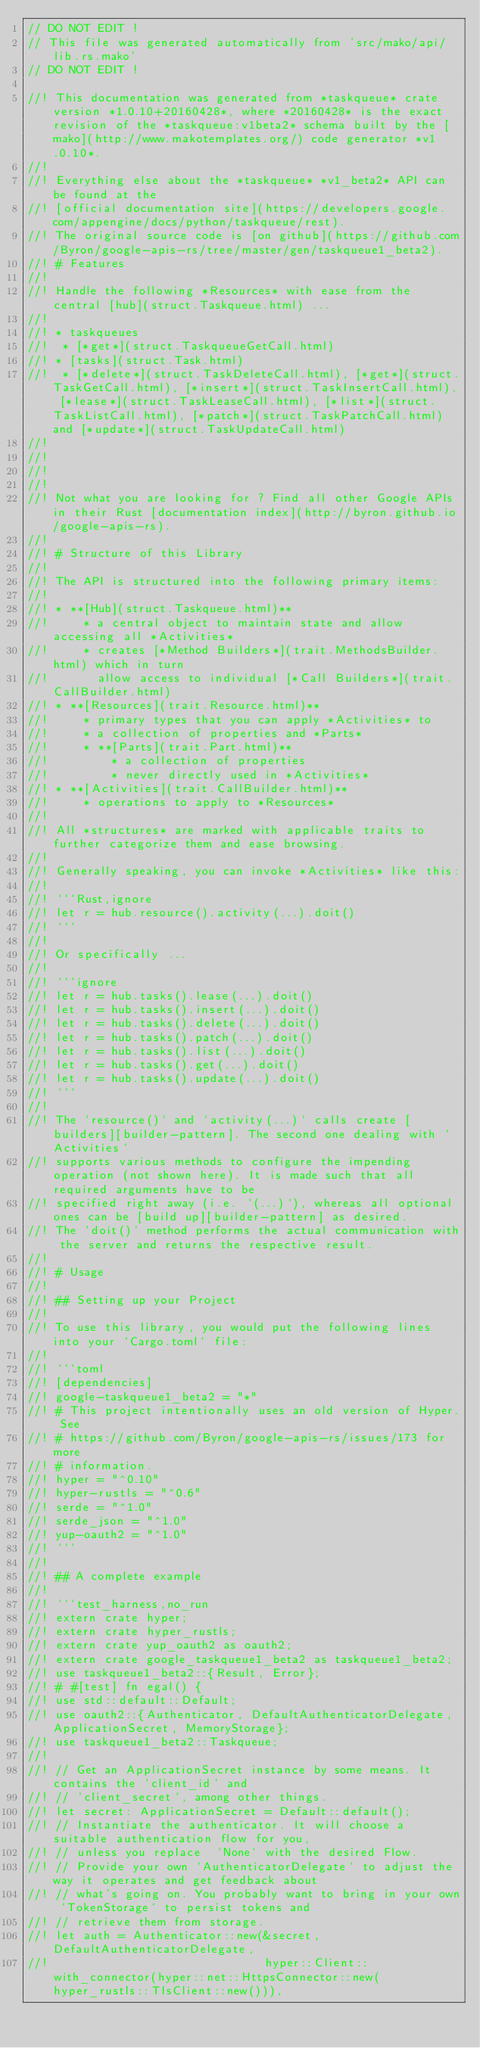<code> <loc_0><loc_0><loc_500><loc_500><_Rust_>// DO NOT EDIT !
// This file was generated automatically from 'src/mako/api/lib.rs.mako'
// DO NOT EDIT !

//! This documentation was generated from *taskqueue* crate version *1.0.10+20160428*, where *20160428* is the exact revision of the *taskqueue:v1beta2* schema built by the [mako](http://www.makotemplates.org/) code generator *v1.0.10*.
//! 
//! Everything else about the *taskqueue* *v1_beta2* API can be found at the
//! [official documentation site](https://developers.google.com/appengine/docs/python/taskqueue/rest).
//! The original source code is [on github](https://github.com/Byron/google-apis-rs/tree/master/gen/taskqueue1_beta2).
//! # Features
//! 
//! Handle the following *Resources* with ease from the central [hub](struct.Taskqueue.html) ... 
//! 
//! * taskqueues
//!  * [*get*](struct.TaskqueueGetCall.html)
//! * [tasks](struct.Task.html)
//!  * [*delete*](struct.TaskDeleteCall.html), [*get*](struct.TaskGetCall.html), [*insert*](struct.TaskInsertCall.html), [*lease*](struct.TaskLeaseCall.html), [*list*](struct.TaskListCall.html), [*patch*](struct.TaskPatchCall.html) and [*update*](struct.TaskUpdateCall.html)
//! 
//! 
//! 
//! 
//! Not what you are looking for ? Find all other Google APIs in their Rust [documentation index](http://byron.github.io/google-apis-rs).
//! 
//! # Structure of this Library
//! 
//! The API is structured into the following primary items:
//! 
//! * **[Hub](struct.Taskqueue.html)**
//!     * a central object to maintain state and allow accessing all *Activities*
//!     * creates [*Method Builders*](trait.MethodsBuilder.html) which in turn
//!       allow access to individual [*Call Builders*](trait.CallBuilder.html)
//! * **[Resources](trait.Resource.html)**
//!     * primary types that you can apply *Activities* to
//!     * a collection of properties and *Parts*
//!     * **[Parts](trait.Part.html)**
//!         * a collection of properties
//!         * never directly used in *Activities*
//! * **[Activities](trait.CallBuilder.html)**
//!     * operations to apply to *Resources*
//! 
//! All *structures* are marked with applicable traits to further categorize them and ease browsing.
//! 
//! Generally speaking, you can invoke *Activities* like this:
//! 
//! ```Rust,ignore
//! let r = hub.resource().activity(...).doit()
//! ```
//! 
//! Or specifically ...
//! 
//! ```ignore
//! let r = hub.tasks().lease(...).doit()
//! let r = hub.tasks().insert(...).doit()
//! let r = hub.tasks().delete(...).doit()
//! let r = hub.tasks().patch(...).doit()
//! let r = hub.tasks().list(...).doit()
//! let r = hub.tasks().get(...).doit()
//! let r = hub.tasks().update(...).doit()
//! ```
//! 
//! The `resource()` and `activity(...)` calls create [builders][builder-pattern]. The second one dealing with `Activities` 
//! supports various methods to configure the impending operation (not shown here). It is made such that all required arguments have to be 
//! specified right away (i.e. `(...)`), whereas all optional ones can be [build up][builder-pattern] as desired.
//! The `doit()` method performs the actual communication with the server and returns the respective result.
//! 
//! # Usage
//! 
//! ## Setting up your Project
//! 
//! To use this library, you would put the following lines into your `Cargo.toml` file:
//! 
//! ```toml
//! [dependencies]
//! google-taskqueue1_beta2 = "*"
//! # This project intentionally uses an old version of Hyper. See
//! # https://github.com/Byron/google-apis-rs/issues/173 for more
//! # information.
//! hyper = "^0.10"
//! hyper-rustls = "^0.6"
//! serde = "^1.0"
//! serde_json = "^1.0"
//! yup-oauth2 = "^1.0"
//! ```
//! 
//! ## A complete example
//! 
//! ```test_harness,no_run
//! extern crate hyper;
//! extern crate hyper_rustls;
//! extern crate yup_oauth2 as oauth2;
//! extern crate google_taskqueue1_beta2 as taskqueue1_beta2;
//! use taskqueue1_beta2::{Result, Error};
//! # #[test] fn egal() {
//! use std::default::Default;
//! use oauth2::{Authenticator, DefaultAuthenticatorDelegate, ApplicationSecret, MemoryStorage};
//! use taskqueue1_beta2::Taskqueue;
//! 
//! // Get an ApplicationSecret instance by some means. It contains the `client_id` and 
//! // `client_secret`, among other things.
//! let secret: ApplicationSecret = Default::default();
//! // Instantiate the authenticator. It will choose a suitable authentication flow for you, 
//! // unless you replace  `None` with the desired Flow.
//! // Provide your own `AuthenticatorDelegate` to adjust the way it operates and get feedback about 
//! // what's going on. You probably want to bring in your own `TokenStorage` to persist tokens and
//! // retrieve them from storage.
//! let auth = Authenticator::new(&secret, DefaultAuthenticatorDelegate,
//!                               hyper::Client::with_connector(hyper::net::HttpsConnector::new(hyper_rustls::TlsClient::new())),</code> 